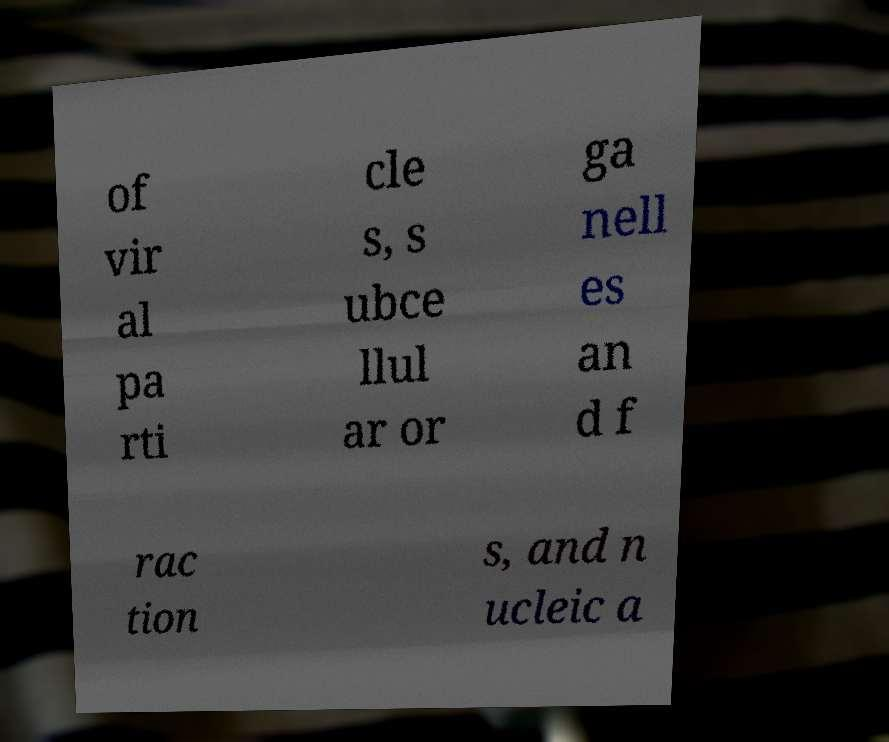Can you read and provide the text displayed in the image?This photo seems to have some interesting text. Can you extract and type it out for me? of vir al pa rti cle s, s ubce llul ar or ga nell es an d f rac tion s, and n ucleic a 